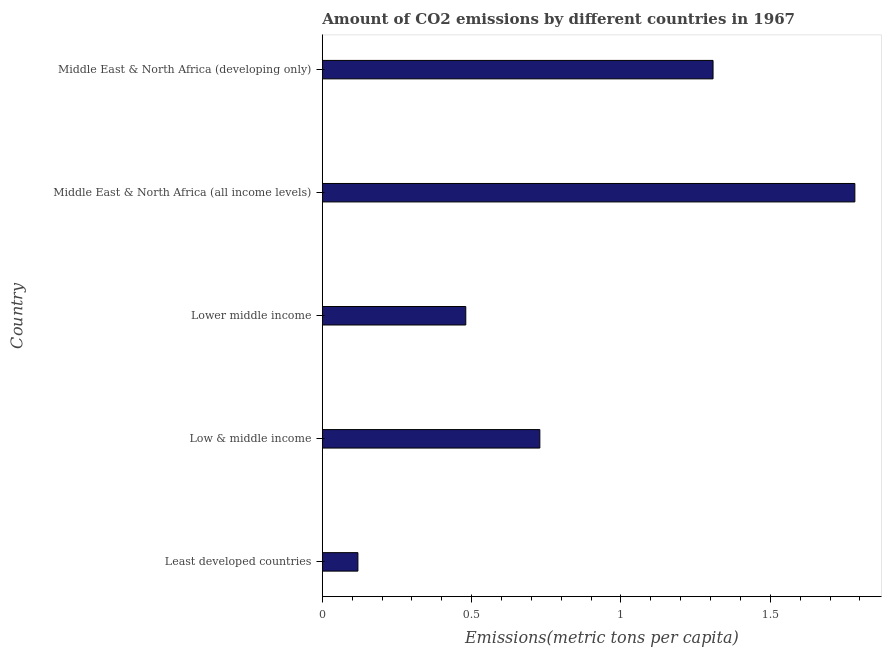Does the graph contain any zero values?
Make the answer very short. No. What is the title of the graph?
Your answer should be compact. Amount of CO2 emissions by different countries in 1967. What is the label or title of the X-axis?
Provide a short and direct response. Emissions(metric tons per capita). What is the amount of co2 emissions in Low & middle income?
Keep it short and to the point. 0.73. Across all countries, what is the maximum amount of co2 emissions?
Your answer should be compact. 1.78. Across all countries, what is the minimum amount of co2 emissions?
Your answer should be very brief. 0.12. In which country was the amount of co2 emissions maximum?
Offer a very short reply. Middle East & North Africa (all income levels). In which country was the amount of co2 emissions minimum?
Make the answer very short. Least developed countries. What is the sum of the amount of co2 emissions?
Your response must be concise. 4.42. What is the difference between the amount of co2 emissions in Least developed countries and Middle East & North Africa (all income levels)?
Your answer should be very brief. -1.66. What is the average amount of co2 emissions per country?
Your answer should be compact. 0.88. What is the median amount of co2 emissions?
Offer a very short reply. 0.73. What is the ratio of the amount of co2 emissions in Least developed countries to that in Middle East & North Africa (all income levels)?
Provide a succinct answer. 0.07. What is the difference between the highest and the second highest amount of co2 emissions?
Make the answer very short. 0.47. What is the difference between the highest and the lowest amount of co2 emissions?
Offer a terse response. 1.66. How many countries are there in the graph?
Give a very brief answer. 5. What is the difference between two consecutive major ticks on the X-axis?
Your response must be concise. 0.5. What is the Emissions(metric tons per capita) of Least developed countries?
Provide a succinct answer. 0.12. What is the Emissions(metric tons per capita) of Low & middle income?
Make the answer very short. 0.73. What is the Emissions(metric tons per capita) of Lower middle income?
Provide a succinct answer. 0.48. What is the Emissions(metric tons per capita) in Middle East & North Africa (all income levels)?
Your answer should be very brief. 1.78. What is the Emissions(metric tons per capita) of Middle East & North Africa (developing only)?
Keep it short and to the point. 1.31. What is the difference between the Emissions(metric tons per capita) in Least developed countries and Low & middle income?
Provide a short and direct response. -0.61. What is the difference between the Emissions(metric tons per capita) in Least developed countries and Lower middle income?
Offer a very short reply. -0.36. What is the difference between the Emissions(metric tons per capita) in Least developed countries and Middle East & North Africa (all income levels)?
Provide a succinct answer. -1.66. What is the difference between the Emissions(metric tons per capita) in Least developed countries and Middle East & North Africa (developing only)?
Keep it short and to the point. -1.19. What is the difference between the Emissions(metric tons per capita) in Low & middle income and Lower middle income?
Offer a terse response. 0.25. What is the difference between the Emissions(metric tons per capita) in Low & middle income and Middle East & North Africa (all income levels)?
Ensure brevity in your answer.  -1.05. What is the difference between the Emissions(metric tons per capita) in Low & middle income and Middle East & North Africa (developing only)?
Your answer should be very brief. -0.58. What is the difference between the Emissions(metric tons per capita) in Lower middle income and Middle East & North Africa (all income levels)?
Offer a very short reply. -1.3. What is the difference between the Emissions(metric tons per capita) in Lower middle income and Middle East & North Africa (developing only)?
Give a very brief answer. -0.83. What is the difference between the Emissions(metric tons per capita) in Middle East & North Africa (all income levels) and Middle East & North Africa (developing only)?
Offer a very short reply. 0.47. What is the ratio of the Emissions(metric tons per capita) in Least developed countries to that in Low & middle income?
Your response must be concise. 0.16. What is the ratio of the Emissions(metric tons per capita) in Least developed countries to that in Lower middle income?
Your answer should be compact. 0.25. What is the ratio of the Emissions(metric tons per capita) in Least developed countries to that in Middle East & North Africa (all income levels)?
Provide a succinct answer. 0.07. What is the ratio of the Emissions(metric tons per capita) in Least developed countries to that in Middle East & North Africa (developing only)?
Your answer should be very brief. 0.09. What is the ratio of the Emissions(metric tons per capita) in Low & middle income to that in Lower middle income?
Your answer should be very brief. 1.52. What is the ratio of the Emissions(metric tons per capita) in Low & middle income to that in Middle East & North Africa (all income levels)?
Your answer should be compact. 0.41. What is the ratio of the Emissions(metric tons per capita) in Low & middle income to that in Middle East & North Africa (developing only)?
Make the answer very short. 0.56. What is the ratio of the Emissions(metric tons per capita) in Lower middle income to that in Middle East & North Africa (all income levels)?
Provide a succinct answer. 0.27. What is the ratio of the Emissions(metric tons per capita) in Lower middle income to that in Middle East & North Africa (developing only)?
Your answer should be very brief. 0.37. What is the ratio of the Emissions(metric tons per capita) in Middle East & North Africa (all income levels) to that in Middle East & North Africa (developing only)?
Provide a short and direct response. 1.36. 